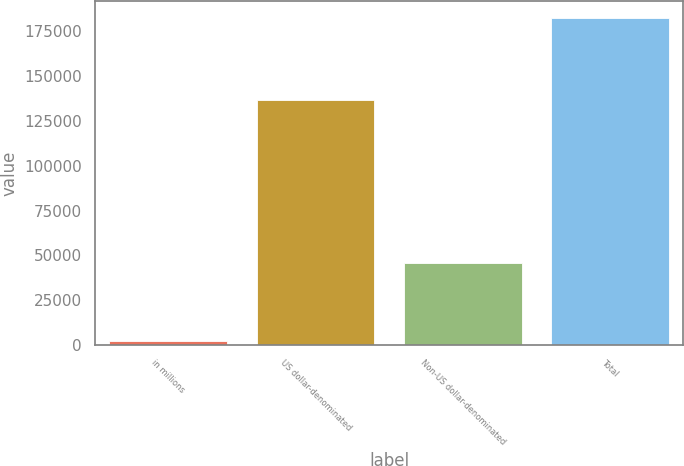Convert chart. <chart><loc_0><loc_0><loc_500><loc_500><bar_chart><fcel>in millions<fcel>US dollar-denominated<fcel>Non-US dollar-denominated<fcel>Total<nl><fcel>2013<fcel>136824<fcel>45826<fcel>182650<nl></chart> 